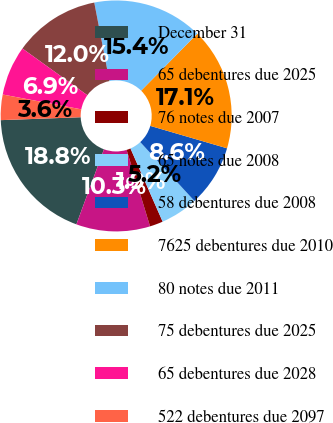Convert chart to OTSL. <chart><loc_0><loc_0><loc_500><loc_500><pie_chart><fcel>December 31<fcel>65 debentures due 2025<fcel>76 notes due 2007<fcel>65 notes due 2008<fcel>58 debentures due 2008<fcel>7625 debentures due 2010<fcel>80 notes due 2011<fcel>75 debentures due 2025<fcel>65 debentures due 2028<fcel>522 debentures due 2097<nl><fcel>18.82%<fcel>10.34%<fcel>1.85%<fcel>5.25%<fcel>8.64%<fcel>17.13%<fcel>15.43%<fcel>12.04%<fcel>6.95%<fcel>3.55%<nl></chart> 